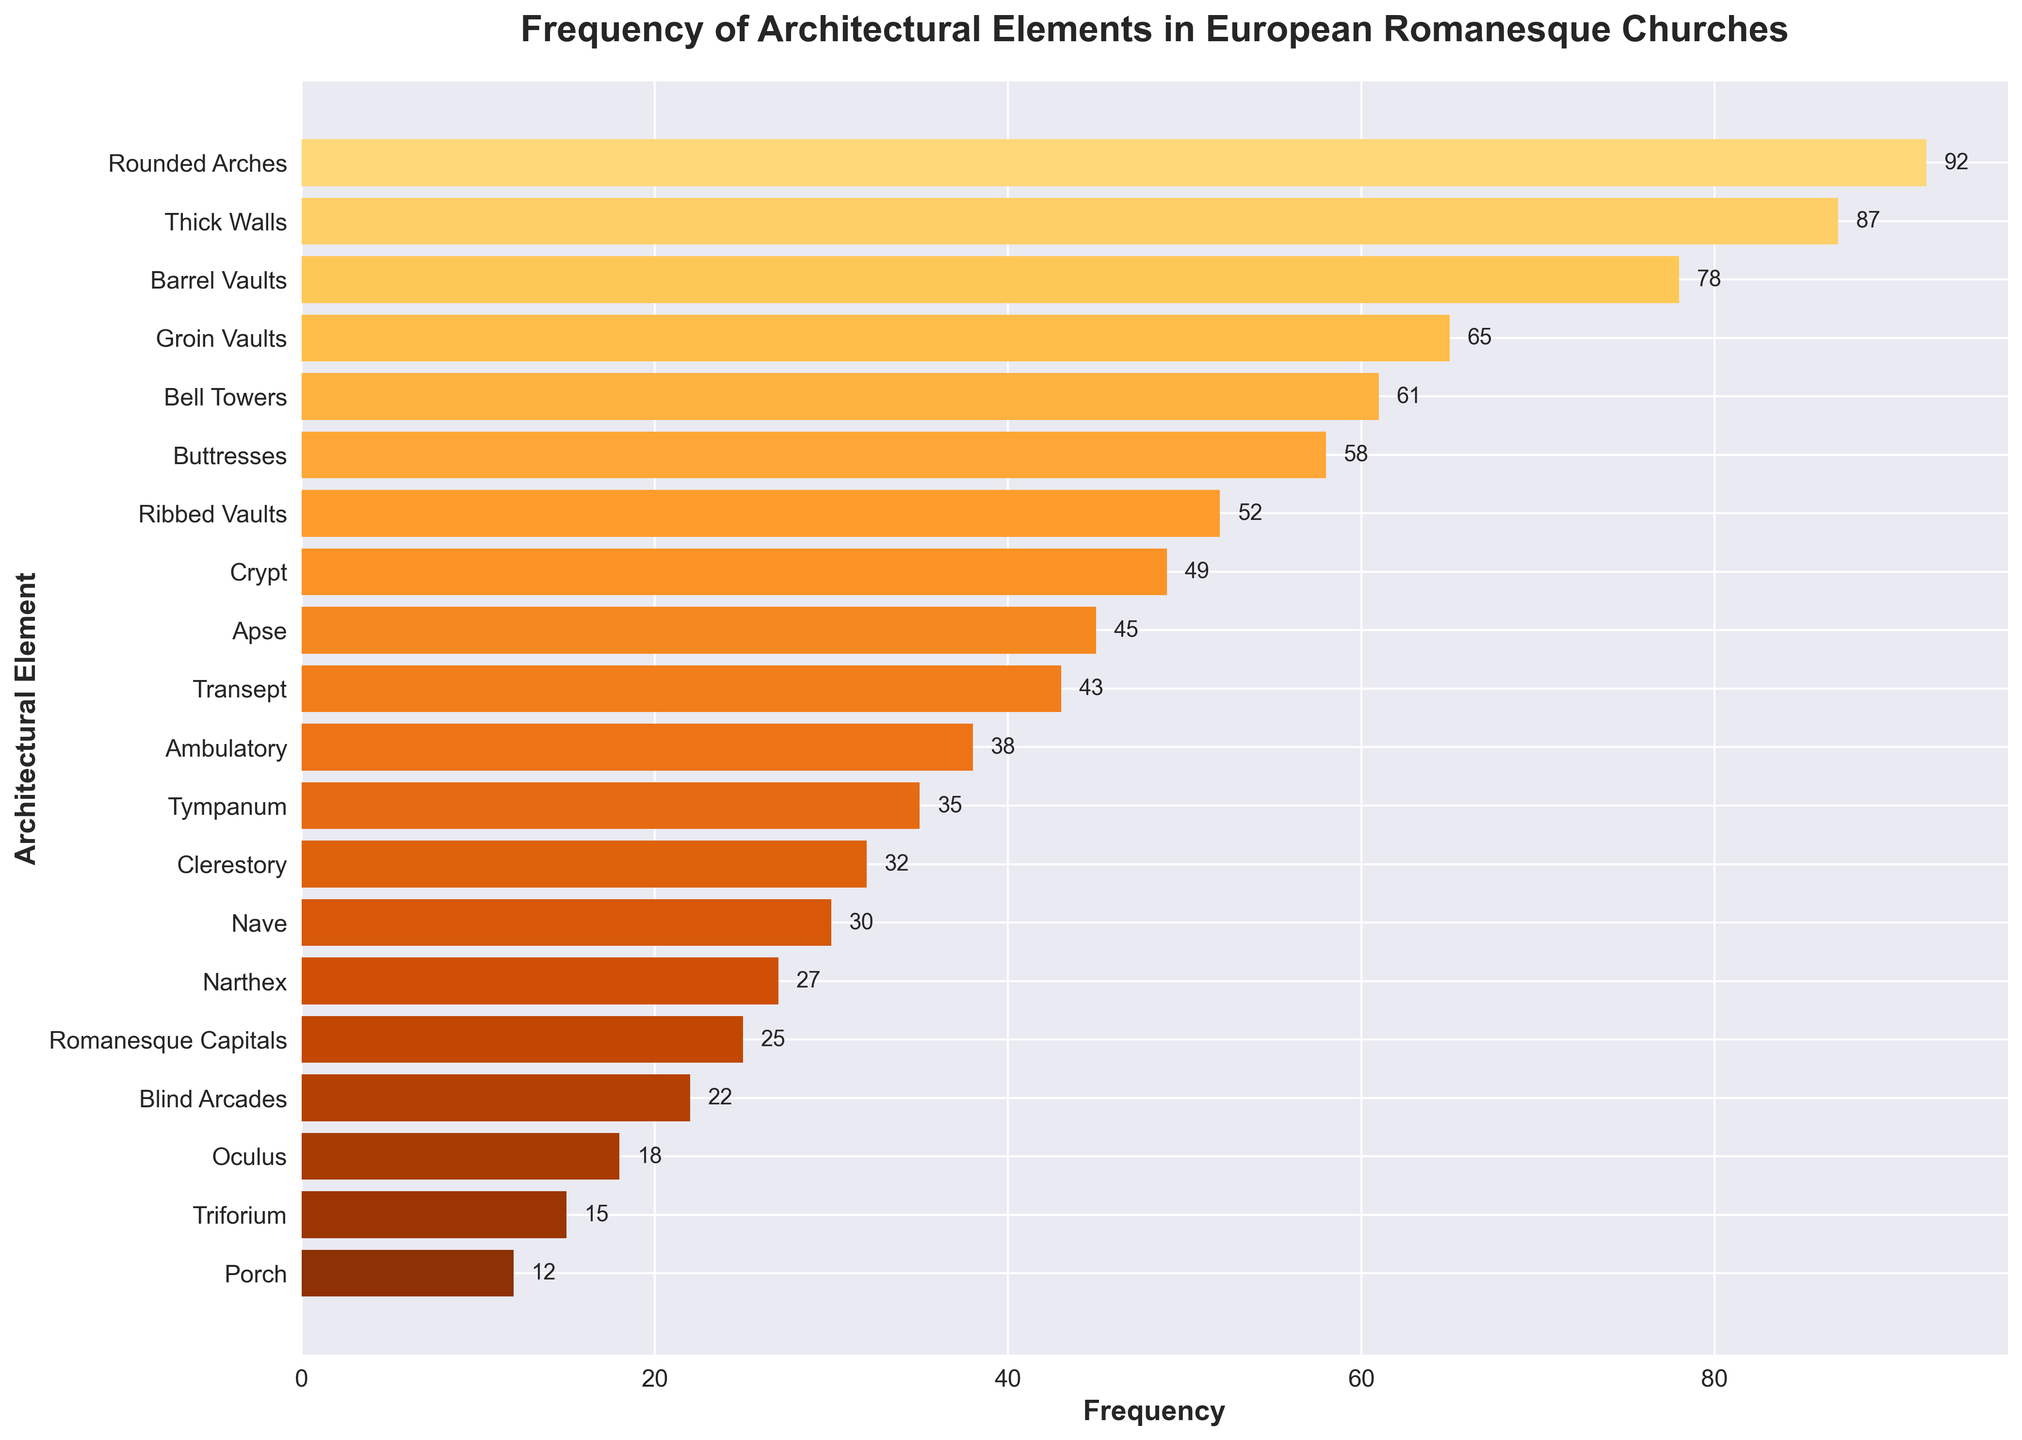What is the most frequent architectural element in the chart? Observe the bar heights and the labels; the tallest bar corresponds to "Rounded Arches" with a frequency of 92.
Answer: Rounded Arches Which architectural element has the lowest frequency and what is it? Identify the shortest bar in the chart, which corresponds to "Porch" with a frequency of 12.
Answer: Porch How many elements have a frequency greater than 50? Count the bars with a frequency value above 50: Rounded Arches, Thick Walls, Barrel Vaults, Groin Vaults, Bell Towers, and Buttresses. There are 6 such elements.
Answer: 6 What is the combined frequency of elements with "Vault" in their name? Summing up the frequencies of "Barrel Vaults" (78), "Groin Vaults" (65), and "Ribbed Vaults" (52) gives 78 + 65 + 52 = 195.
Answer: 195 Which architectural element has a frequency closest to 50? Checking bars around the middle frequency values shows that "Crypt" has a frequency of 49.
Answer: Crypt How many elements have a frequency between 40 and 70? Identify bars with frequency values between 40 and 70: Groin Vaults, Bell Towers, Buttresses, Crypt, and Apse. There are 5 such elements.
Answer: 5 Which is more frequent: Narthex or Nave? Compare the bars for "Narthex" (27) and "Nave" (30); "Nave" has a higher frequency.
Answer: Nave Are there more elements with a frequency below 30 or above 50? Count elements below 30: Narthex, Romanesque Capitals, Blind Arcades, Oculus, Triforium, and Porch (6 elements). Count elements above 50: Rounded Arches, Thick Walls, Barrel Vaults, Groin Vaults, Bell Towers, Buttresses, Ribbed Vaults (7 elements). There are more elements with a frequency above 50.
Answer: Above 50 What is the average frequency of "Ambulatory" and "Clerestory"? The frequencies of "Ambulatory" (38) and "Clerestory" (32) sum to 70. The average frequency is 70/2 = 35.
Answer: 35 